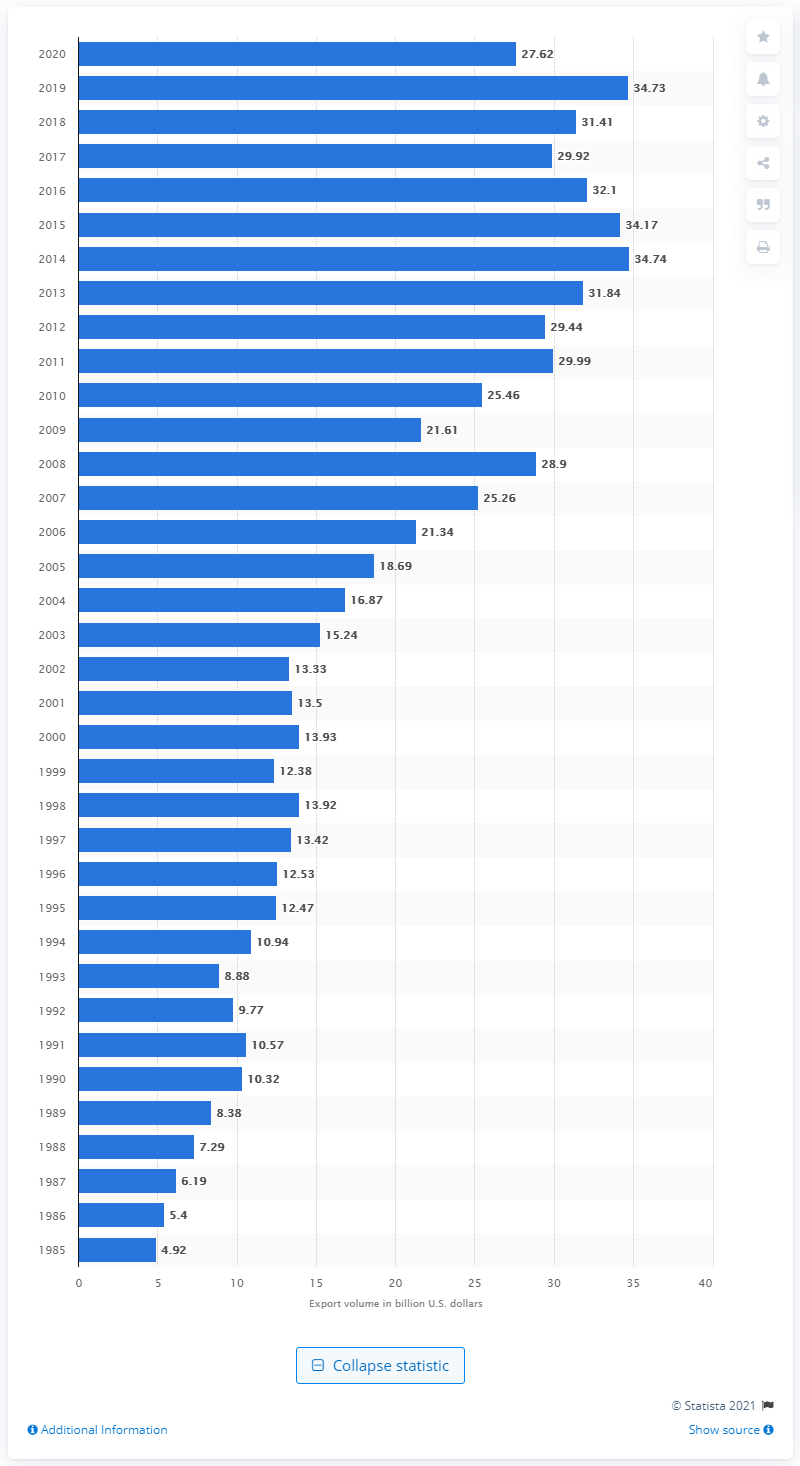Mention a couple of crucial points in this snapshot. In 2020, the United States exported 27.62 billion dollars to Belgium. 